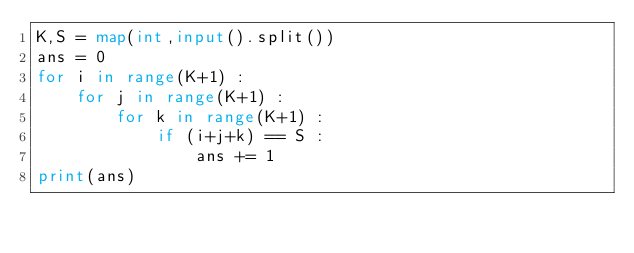<code> <loc_0><loc_0><loc_500><loc_500><_Python_>K,S = map(int,input().split())
ans = 0
for i in range(K+1) :
    for j in range(K+1) :
        for k in range(K+1) :
            if (i+j+k) == S :
                ans += 1
print(ans)
</code> 